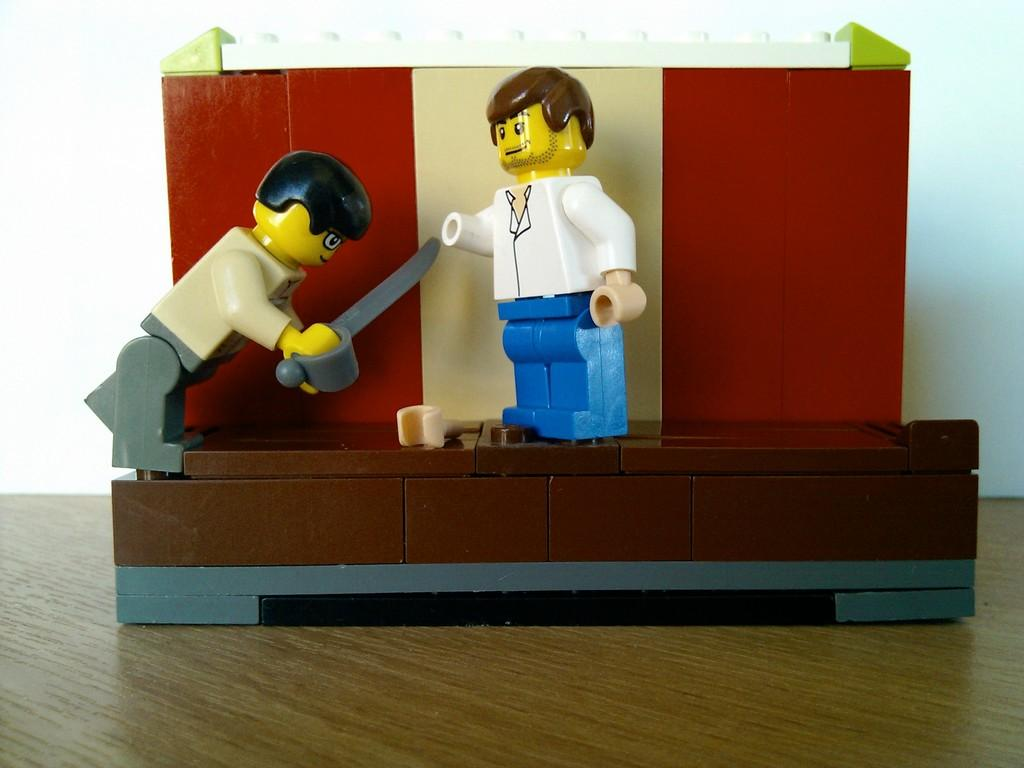What object can be seen in the image? There is a toy in the image. On what surface is the toy placed? The toy is on a wooden surface. What can be seen in the background of the image? There is a white color wall in the background of the image. What type of brush can be seen in the image? There is no brush present in the image; it features a toy on a wooden surface with a white color wall in the background. 